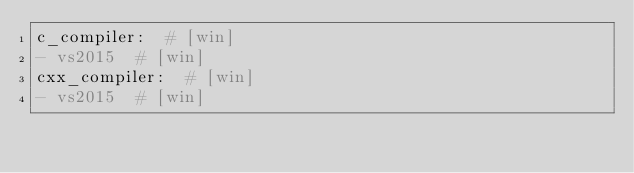Convert code to text. <code><loc_0><loc_0><loc_500><loc_500><_YAML_>c_compiler:  # [win]
- vs2015  # [win]
cxx_compiler:  # [win]
- vs2015  # [win]
</code> 